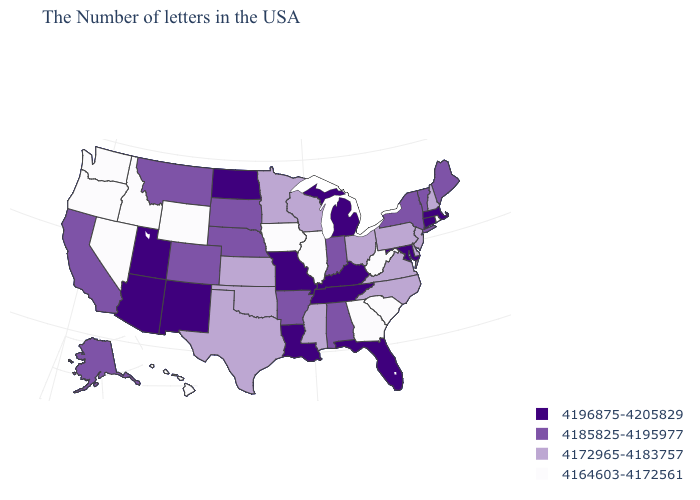What is the value of Pennsylvania?
Answer briefly. 4172965-4183757. Which states have the lowest value in the USA?
Answer briefly. Rhode Island, South Carolina, West Virginia, Georgia, Illinois, Iowa, Wyoming, Idaho, Nevada, Washington, Oregon, Hawaii. Name the states that have a value in the range 4196875-4205829?
Be succinct. Massachusetts, Connecticut, Maryland, Florida, Michigan, Kentucky, Tennessee, Louisiana, Missouri, North Dakota, New Mexico, Utah, Arizona. Among the states that border Connecticut , does New York have the lowest value?
Concise answer only. No. Does the first symbol in the legend represent the smallest category?
Give a very brief answer. No. What is the value of Kentucky?
Write a very short answer. 4196875-4205829. Name the states that have a value in the range 4164603-4172561?
Be succinct. Rhode Island, South Carolina, West Virginia, Georgia, Illinois, Iowa, Wyoming, Idaho, Nevada, Washington, Oregon, Hawaii. What is the value of Iowa?
Keep it brief. 4164603-4172561. Does Oregon have the lowest value in the West?
Quick response, please. Yes. How many symbols are there in the legend?
Answer briefly. 4. Does Hawaii have the same value as Texas?
Write a very short answer. No. Which states have the highest value in the USA?
Be succinct. Massachusetts, Connecticut, Maryland, Florida, Michigan, Kentucky, Tennessee, Louisiana, Missouri, North Dakota, New Mexico, Utah, Arizona. How many symbols are there in the legend?
Write a very short answer. 4. Name the states that have a value in the range 4172965-4183757?
Short answer required. New Hampshire, New Jersey, Delaware, Pennsylvania, Virginia, North Carolina, Ohio, Wisconsin, Mississippi, Minnesota, Kansas, Oklahoma, Texas. Does Missouri have a higher value than Illinois?
Short answer required. Yes. 